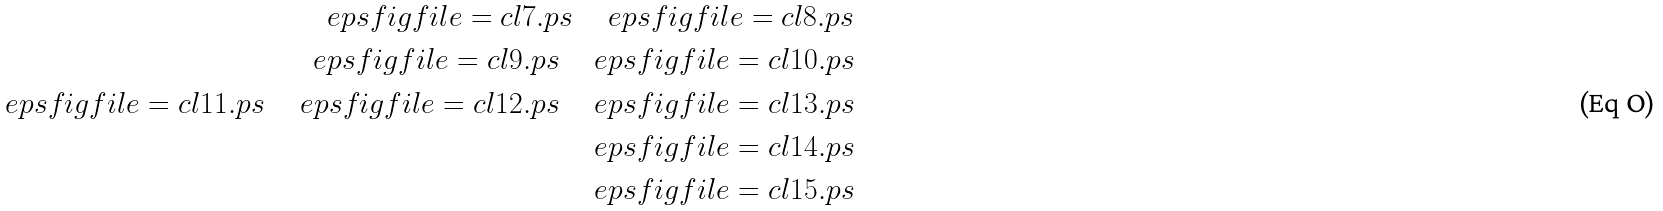Convert formula to latex. <formula><loc_0><loc_0><loc_500><loc_500>\ e p s f i g { f i l e = c l 7 . p s } \quad \ e p s f i g { f i l e = c l 8 . p s } \\ \ e p s f i g { f i l e = c l 9 . p s } \quad \ e p s f i g { f i l e = c l 1 0 . p s } \\ \ e p s f i g { f i l e = c l 1 1 . p s } \quad \ e p s f i g { f i l e = c l 1 2 . p s } \quad \ e p s f i g { f i l e = c l 1 3 . p s } \\ \ e p s f i g { f i l e = c l 1 4 . p s } \\ \ e p s f i g { f i l e = c l 1 5 . p s }</formula> 